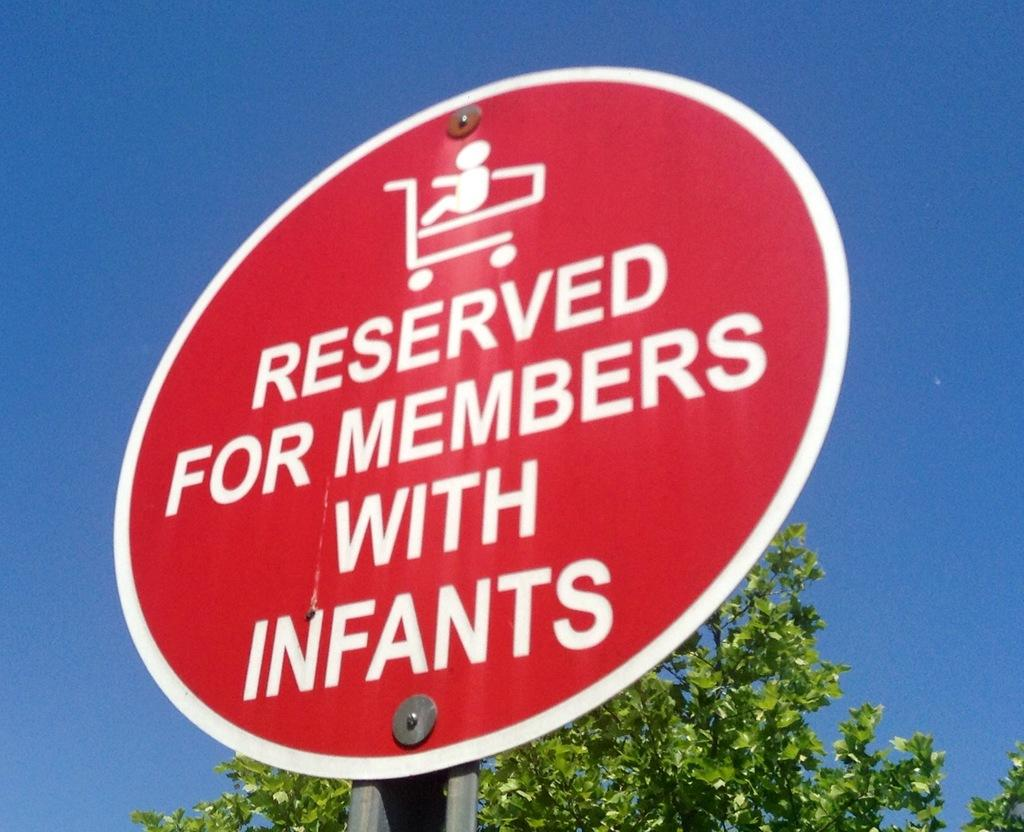Provide a one-sentence caption for the provided image. A circular sign warns that an area is for people with infants. 